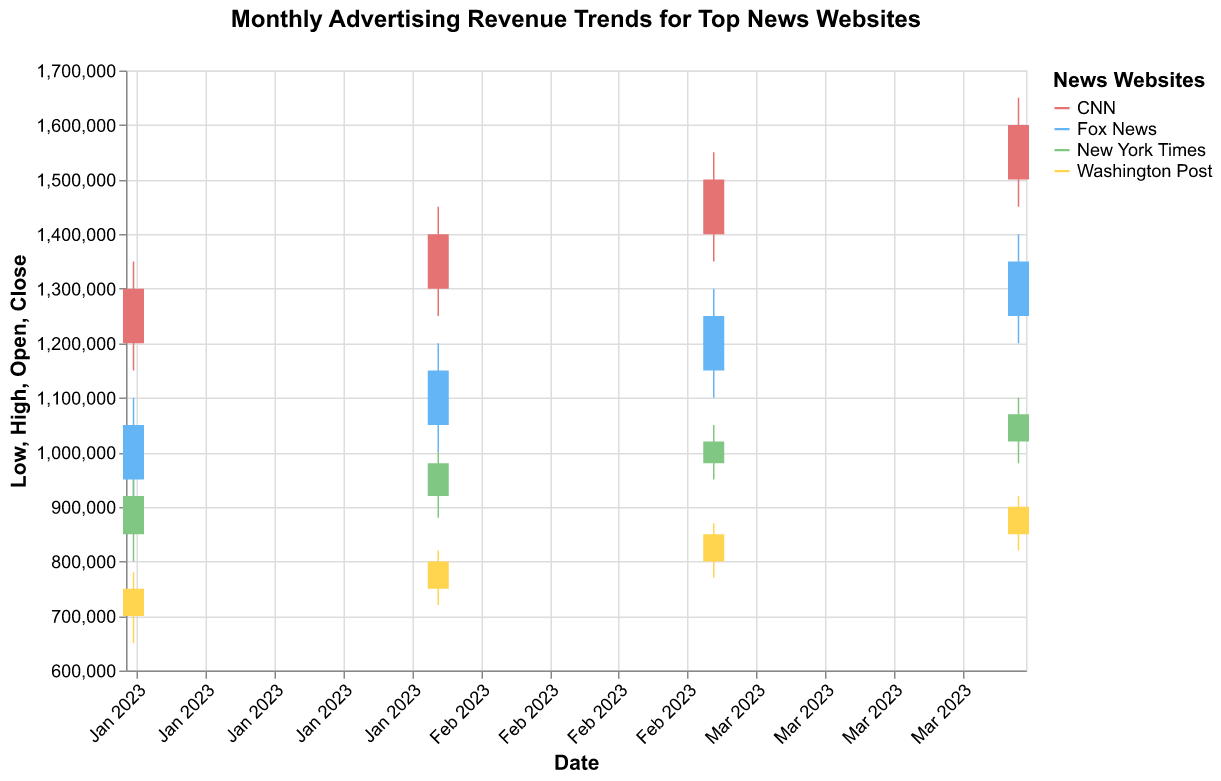Which website had the highest advertising revenue in January 2023? In January 2023, looking at the 'High' values for each website, CNN had the highest advertising revenue with a 'High' value of 1,350,000.
Answer: CNN What was the advertising revenue range for Fox News in February 2023? The revenue range is calculated as the difference between the 'High' and 'Low' values. For Fox News in February 2023, the 'High' value was 1,200,000 and the 'Low' value was 1,000,000. Therefore, the range is 1,200,000 - 1,000,000 = 200,000.
Answer: 200,000 Which website showed the most growth in closing revenue from January to April 2023? The growth is determined by subtracting the January closing revenue from the April closing revenue for each website. CNN's revenue grew from 1,300,000 to 1,600,000, a difference of 300,000. Fox News grew from 1,050,000 to 1,350,000, a difference of 300,000. New York Times grew from 920,000 to 1,070,000, a difference of 150,000. Washington Post grew from 750,000 to 900,000, a difference of 150,000. Both CNN and Fox News showed the most growth with a difference of 300,000 each.
Answer: CNN and Fox News How did the advertising revenue trend for the New York Times change from January to April 2023? The advertising revenue trend for the New York Times can be analyzed by comparing the 'Close' values over the months. It starts from 920,000 in January, increases to 980,000 in February, then to 1,020,000 in March, and finally to 1,070,000 in April. The trend shows a consistent increase in advertising revenue each month.
Answer: Increasing trend What are the seasonal variations in the advertising revenue for Washington Post? Seasonal variations can be observed by looking at the data for each month from January to April. Washington Post's 'Close' values are 750,000 in January, 800,000 in February, 850,000 in March, and 900,000 in April. The revenue shows a steady increase each month, indicating no drastic seasonal drop but a gradual steady increase.
Answer: Steady increase Combine and compare the highest advertising revenue of CNN and Fox News in March 2023. Which one is higher and by how much? For March 2023, CNN had a 'High' value of 1,550,000 and Fox News had a 'High' value of 1,300,000. To compare, subtract Fox News's highest revenue from CNN's highest revenue, which results in 1,550,000 - 1,300,000 = 250,000. CNN's highest advertising revenue was higher by 250,000.
Answer: CNN, by 250,000 